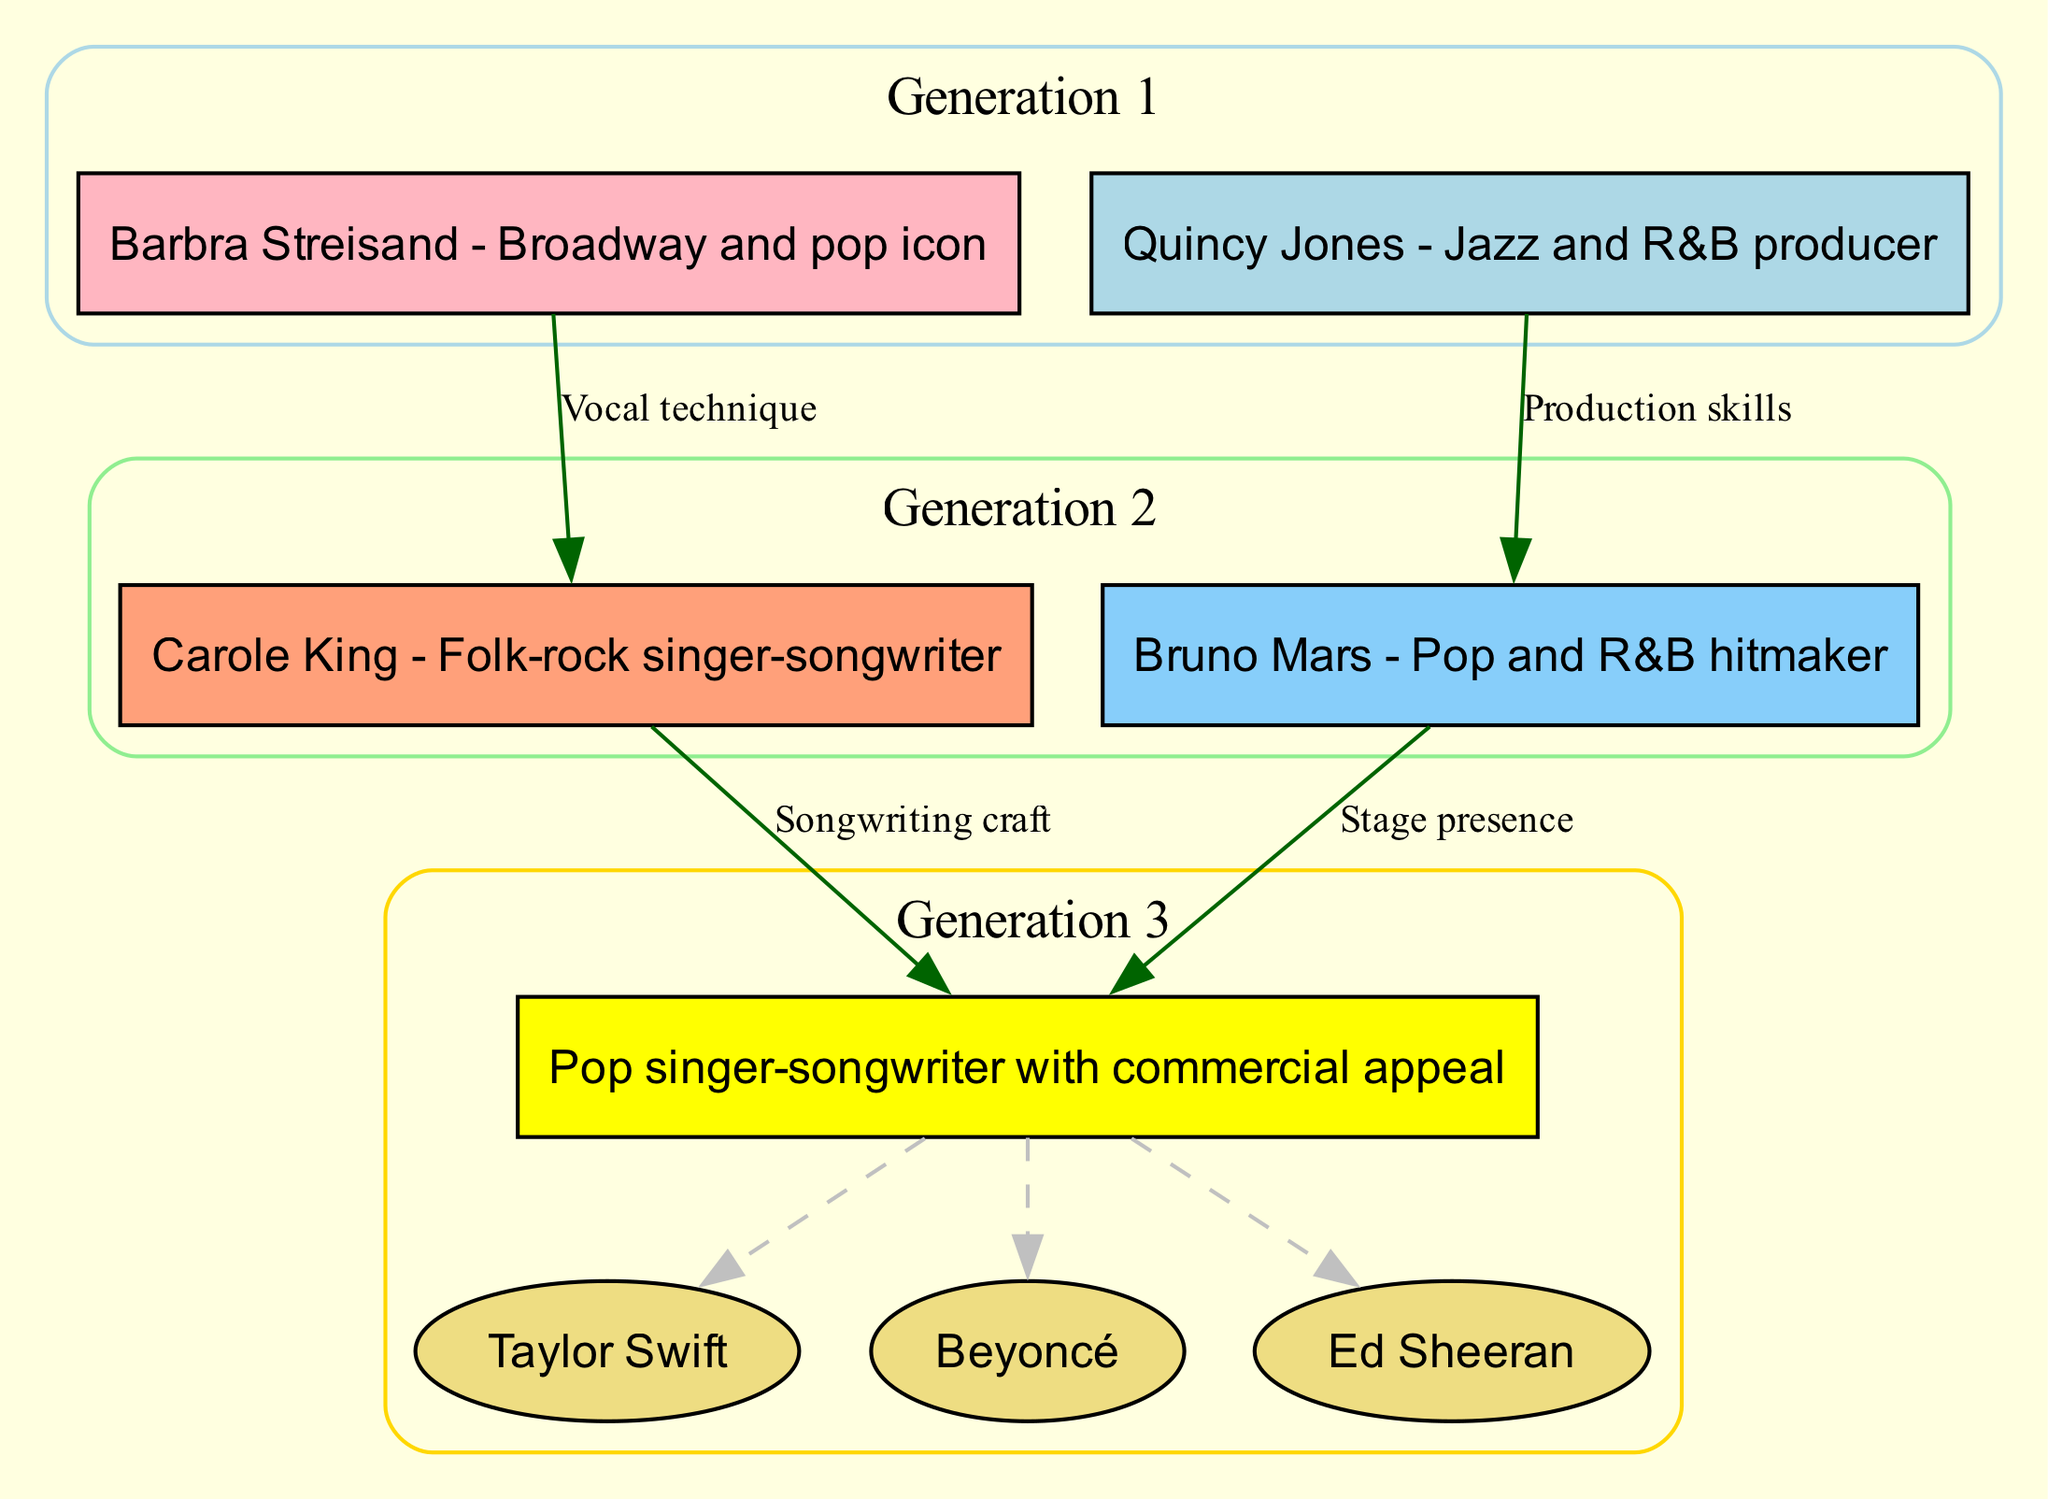What is the profession of the Grandmother? The diagram specifies her identity as "Barbra Streisand - Broadway and pop icon," indicating that she is a Broadway and pop singer.
Answer: Broadway and pop icon Who is the Father? In Generation 2, the diagram names him as "Bruno Mars - Pop and R&B hitmaker," identifying his role as a popular music artist.
Answer: Bruno Mars How many influences are listed in Generation 3? The diagram shows three influences, which are Taylor Swift, Beyoncé, and Ed Sheeran, under the Influences section for Generation 3.
Answer: 3 What skill did the Grandfather pass on to the Father? The diagram states the connection as "Grandfather → Father: Production skills," which specifies that the Grandfather's influence was on production skills.
Answer: Production skills Which influence is tagged as an ellipse shape? The diagram defines the influences in Generation 3 (Taylor Swift, Beyoncé, Ed Sheeran) as being represented by an ellipse shape while the main identity is in a rectangle. Therefore, any influence is in ellipse shape.
Answer: All influences Which generation does Carole King belong to? The diagram indicates that Carole King is listed in Generation 2, specifying her role and era in music as a folk-rock singer-songwriter.
Answer: Generation 2 What label is associated with the connection from Mother to Self? The diagram describes this connection with the label "Songwriting craft," revealing what the Mother passed down to her child.
Answer: Songwriting craft Who are the two parents shown in Generation 2? The diagram outlines both professionals as "Mother: Carole King" and "Father: Bruno Mars," specifying their identities and careers as musical figures.
Answer: Carole King and Bruno Mars What does the connection from Grandmother to Mother indicate? The diagram indicates this link as "Vocal technique," meaning the Grandmother contributed her vocal skills to her daughter.
Answer: Vocal technique 